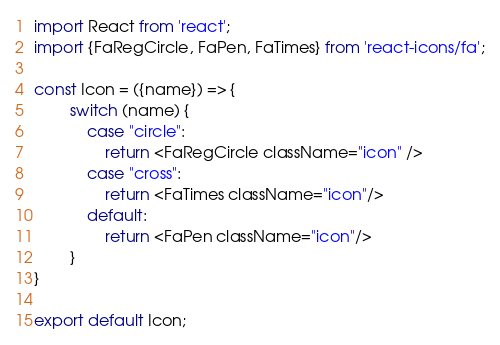<code> <loc_0><loc_0><loc_500><loc_500><_JavaScript_>import React from 'react';
import {FaRegCircle, FaPen, FaTimes} from 'react-icons/fa';

const Icon = ({name}) => {
        switch (name) {
            case "circle":
                return <FaRegCircle className="icon" />
            case "cross":
                return <FaTimes className="icon"/>
            default:
                return <FaPen className="icon"/>
        }
}

export default Icon;</code> 